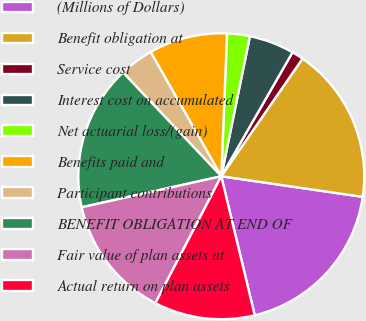Convert chart. <chart><loc_0><loc_0><loc_500><loc_500><pie_chart><fcel>(Millions of Dollars)<fcel>Benefit obligation at<fcel>Service cost<fcel>Interest cost on accumulated<fcel>Net actuarial loss/(gain)<fcel>Benefits paid and<fcel>Participant contributions<fcel>BENEFIT OBLIGATION AT END OF<fcel>Fair value of plan assets at<fcel>Actual return on plan assets<nl><fcel>18.94%<fcel>17.68%<fcel>1.32%<fcel>5.09%<fcel>2.57%<fcel>8.87%<fcel>3.83%<fcel>16.42%<fcel>13.9%<fcel>11.38%<nl></chart> 